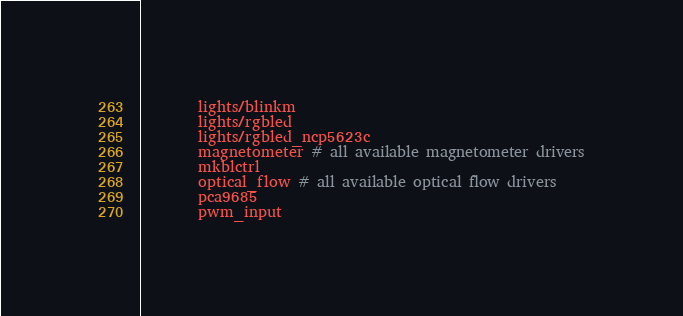Convert code to text. <code><loc_0><loc_0><loc_500><loc_500><_CMake_>		lights/blinkm
		lights/rgbled
		lights/rgbled_ncp5623c
		magnetometer # all available magnetometer drivers
		mkblctrl
		optical_flow # all available optical flow drivers
		pca9685
		pwm_input</code> 